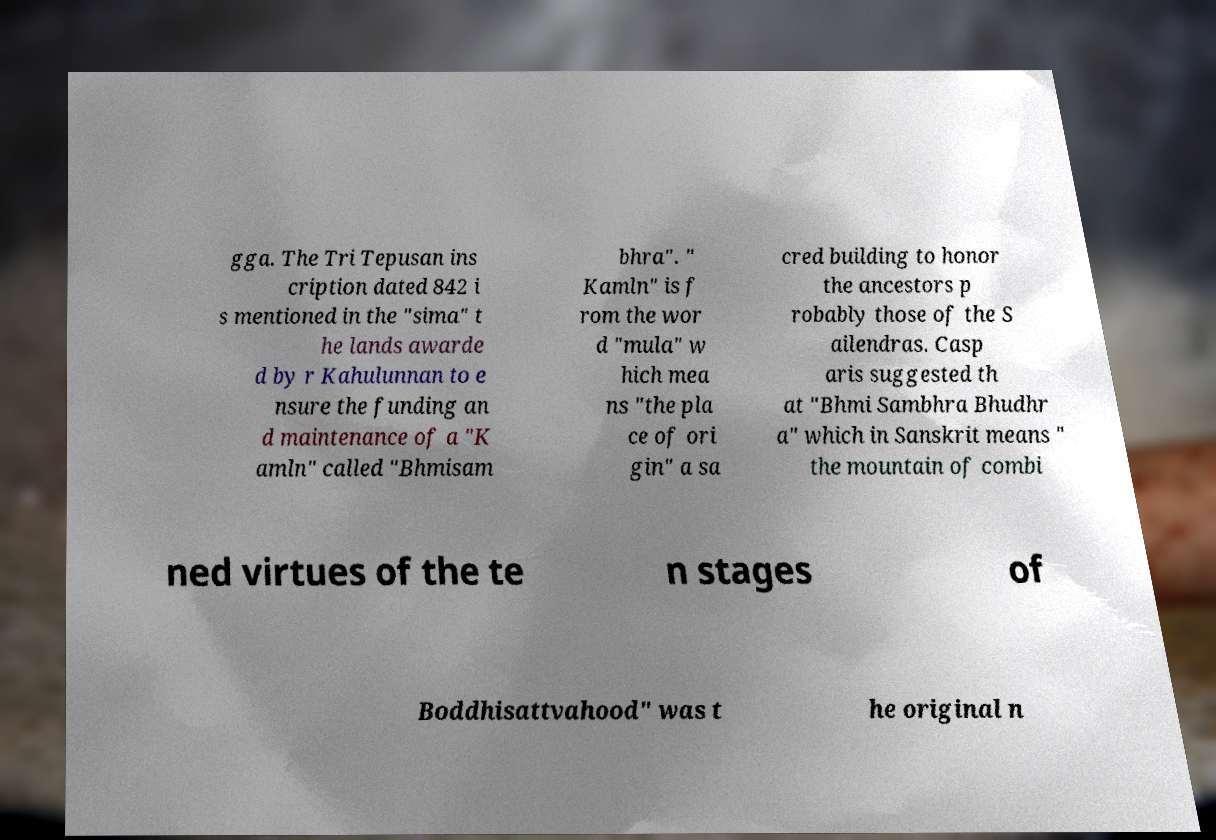Please identify and transcribe the text found in this image. gga. The Tri Tepusan ins cription dated 842 i s mentioned in the "sima" t he lands awarde d by r Kahulunnan to e nsure the funding an d maintenance of a "K amln" called "Bhmisam bhra". " Kamln" is f rom the wor d "mula" w hich mea ns "the pla ce of ori gin" a sa cred building to honor the ancestors p robably those of the S ailendras. Casp aris suggested th at "Bhmi Sambhra Bhudhr a" which in Sanskrit means " the mountain of combi ned virtues of the te n stages of Boddhisattvahood" was t he original n 